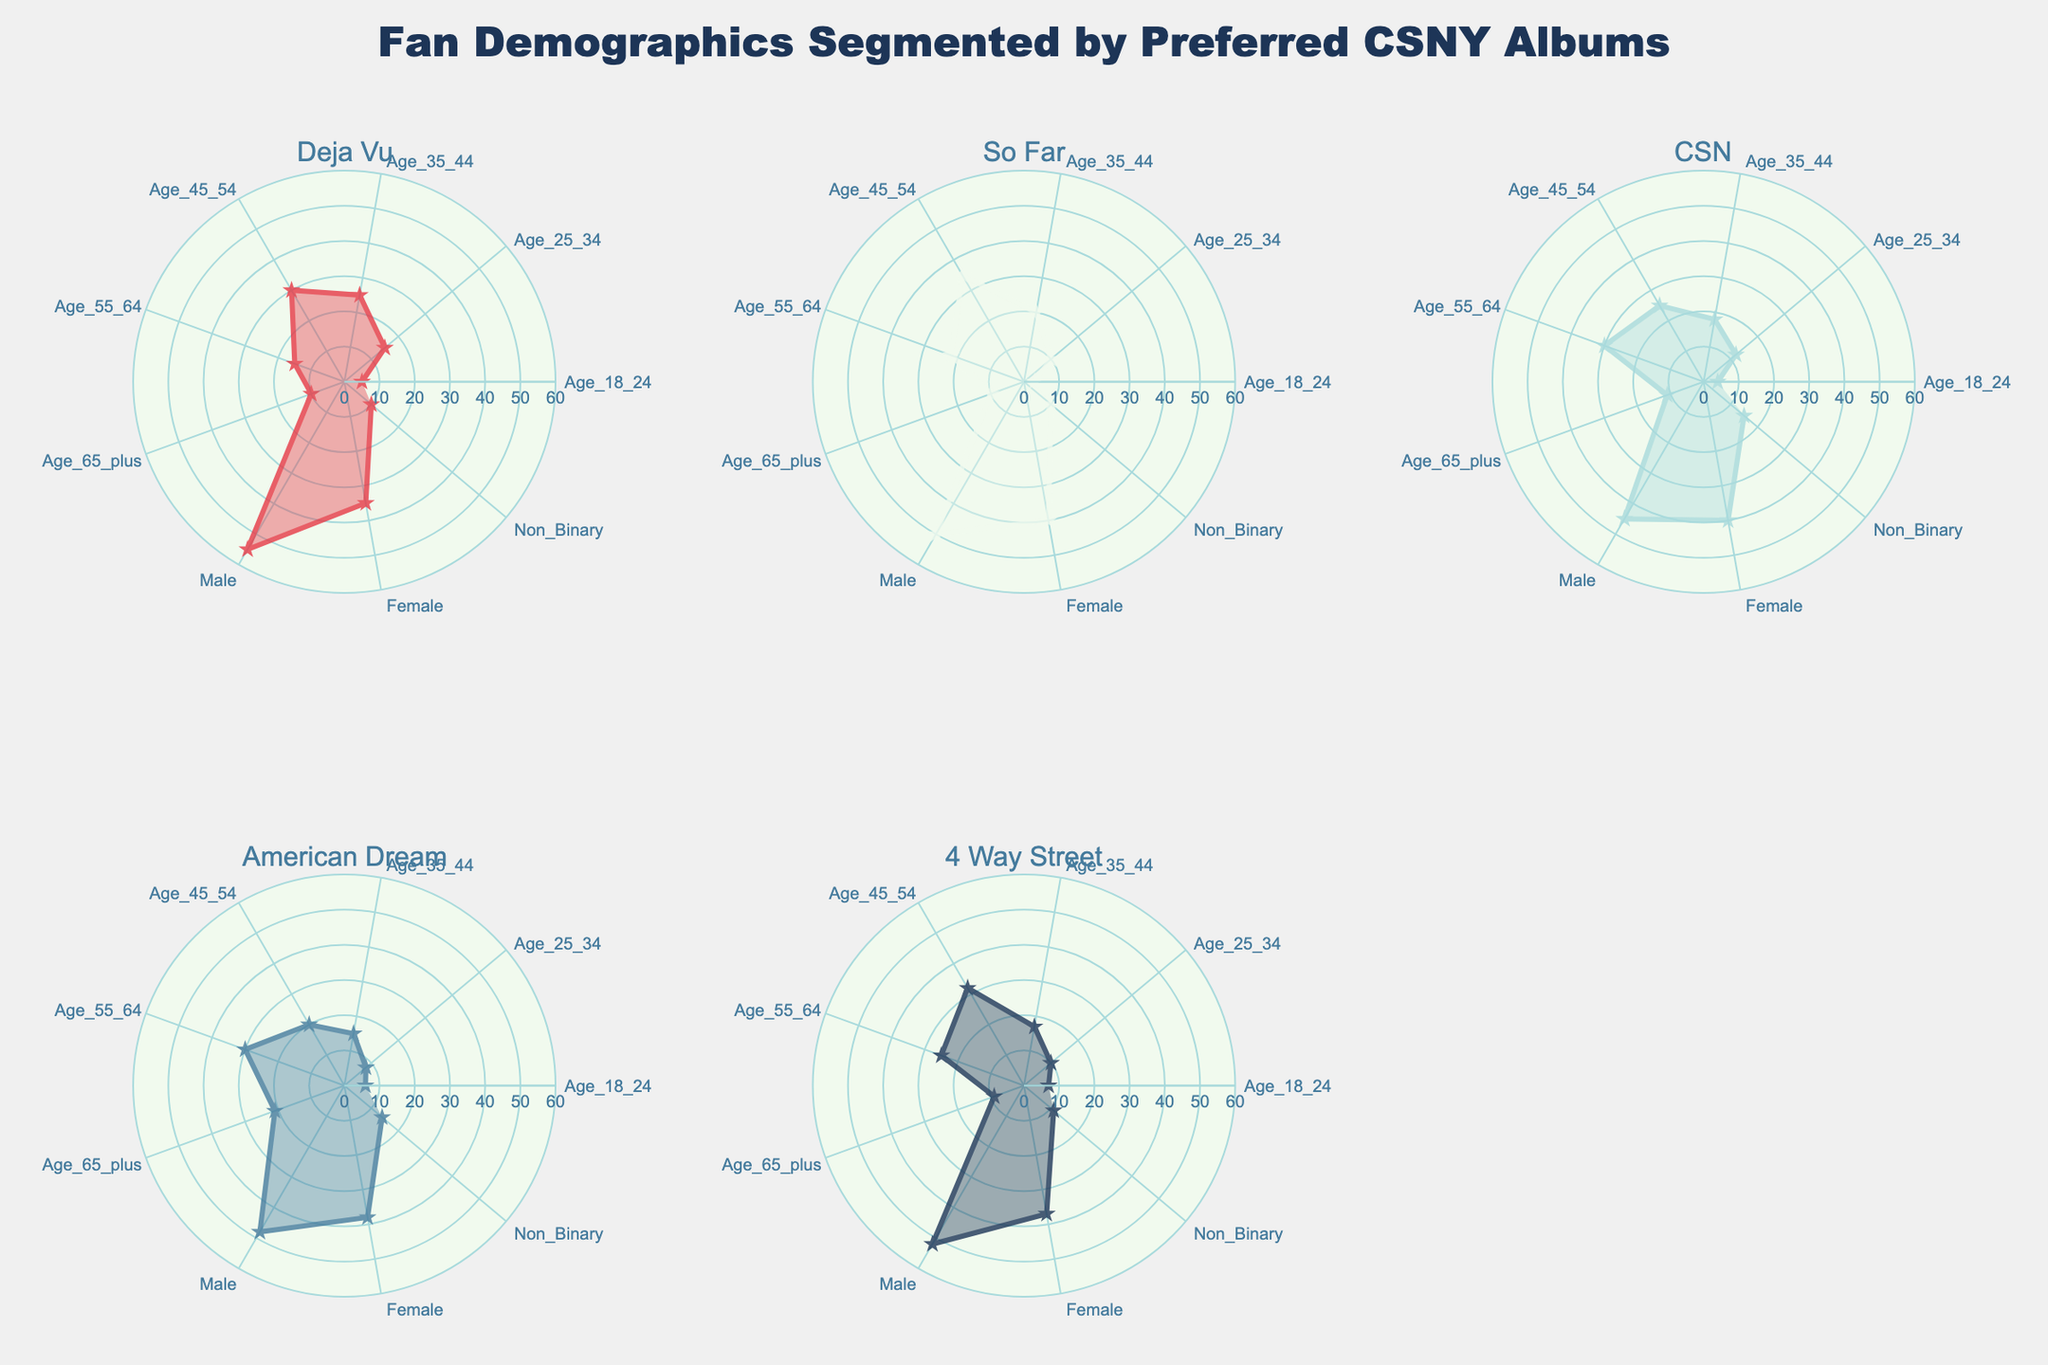What is the title of the figure? The title is located at the top center of the figure; it reads "Fan Demographics Segmented by Preferred CSNY Albums".
Answer: Fan Demographics Segmented by Preferred CSNY Albums Which album has the highest number of fans in the age group 45-54? Look at the radial points on each subplot. "So Far" has the highest value at 35 fans in the 45-54 age group.
Answer: So Far How many total fans identify as Non-Binary across all albums? Add up the Non-Binary values from all the subplots: 10 (Deja Vu) + 10 (So Far) + 15 (CSN) + 14 (American Dream) + 11 (4 Way Street) = 60.
Answer: 60 How does the number of male fans for "Deja Vu" compare to "American Dream"? Look at the male fan segments on both radar charts. "Deja Vu" has 55 male fans, while "American Dream" has 48. Therefore, "Deja Vu" has more.
Answer: Deja Vu has more Which album has the highest number of fans in the age group 55-64? Check the radial segments for each subplot in the 55-64 age group. "CSN" and "American Dream" each have 30 fans, which is the highest among all albums.
Answer: CSN and American Dream How many total female fans prefer the albums "So Far" and "4 Way Street"? Add the female fans of the two albums: 40 (So Far) + 37 (4 Way Street) = 77.
Answer: 77 Which album has the smallest difference between male and female fans? Calculate the difference for each album: Deja Vu (55-35=20), So Far (50-40=10), CSN (45-40=5), American Dream (48-38=10), 4 Way Street (52-37=15). "CSN" has the smallest difference of 5.
Answer: CSN What's the average number of fans aged 18-24 across all albums? Average is calculated by summing the values and dividing by the number of albums: (5 + 3 + 4 + 6 + 7)/5 = 25/5 = 5.
Answer: 5 Which album has the most balanced distribution among all demographic segments? By visually assessing the similarity in radial lengths, "CSN" appears to have the most balanced spread across all demographic segments.
Answer: CSN 